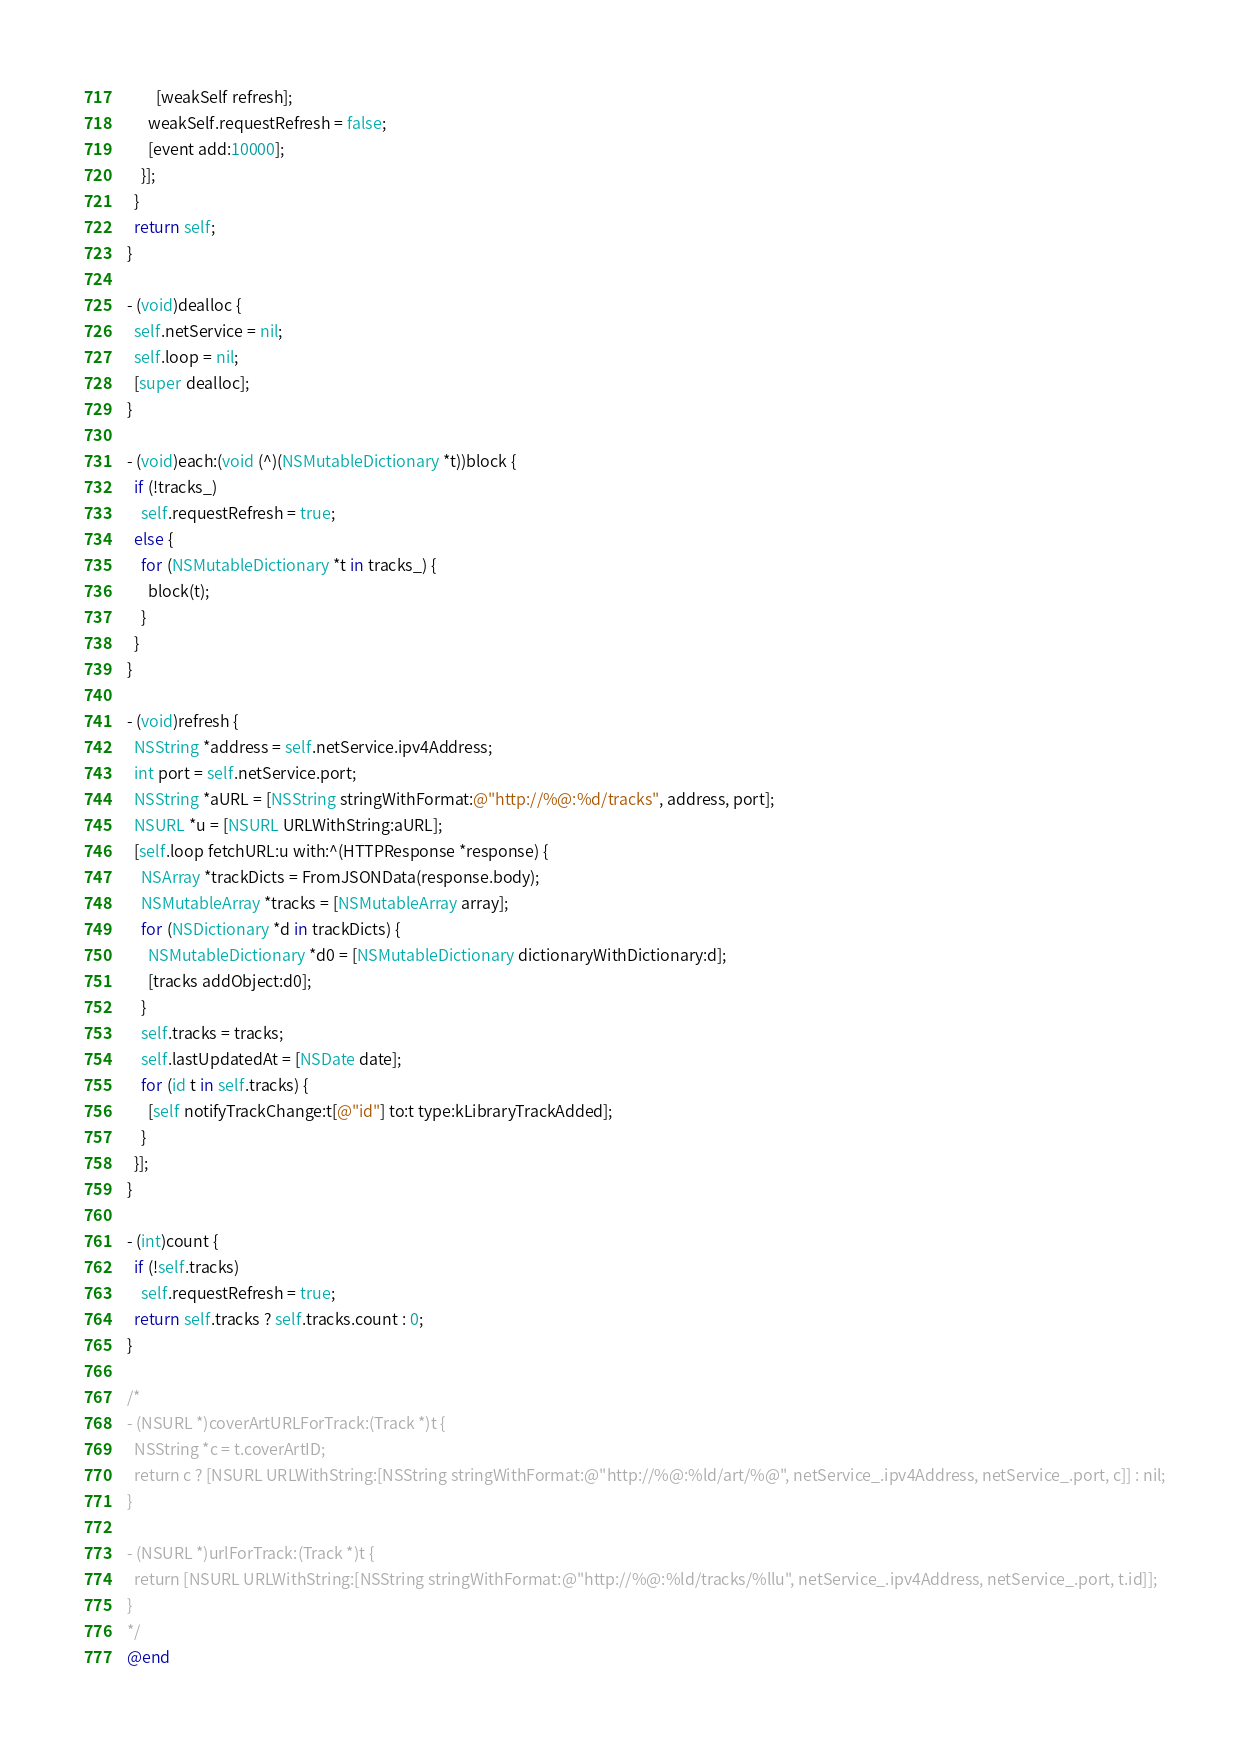Convert code to text. <code><loc_0><loc_0><loc_500><loc_500><_ObjectiveC_>        [weakSelf refresh];
      weakSelf.requestRefresh = false;
      [event add:10000];
    }];
  }
  return self;
}

- (void)dealloc {
  self.netService = nil;
  self.loop = nil;
  [super dealloc];
}

- (void)each:(void (^)(NSMutableDictionary *t))block {
  if (!tracks_)
    self.requestRefresh = true;
  else {
    for (NSMutableDictionary *t in tracks_) {
      block(t);
    }
  }
}

- (void)refresh {
  NSString *address = self.netService.ipv4Address;
  int port = self.netService.port;
  NSString *aURL = [NSString stringWithFormat:@"http://%@:%d/tracks", address, port];
  NSURL *u = [NSURL URLWithString:aURL];
  [self.loop fetchURL:u with:^(HTTPResponse *response) {
    NSArray *trackDicts = FromJSONData(response.body);
    NSMutableArray *tracks = [NSMutableArray array];
    for (NSDictionary *d in trackDicts) {
      NSMutableDictionary *d0 = [NSMutableDictionary dictionaryWithDictionary:d];
      [tracks addObject:d0];
    }
    self.tracks = tracks;
    self.lastUpdatedAt = [NSDate date];
    for (id t in self.tracks) {
      [self notifyTrackChange:t[@"id"] to:t type:kLibraryTrackAdded];
    }
  }];
}

- (int)count {
  if (!self.tracks)
    self.requestRefresh = true;
  return self.tracks ? self.tracks.count : 0;
}

/*
- (NSURL *)coverArtURLForTrack:(Track *)t {
  NSString *c = t.coverArtID;
  return c ? [NSURL URLWithString:[NSString stringWithFormat:@"http://%@:%ld/art/%@", netService_.ipv4Address, netService_.port, c]] : nil;
}

- (NSURL *)urlForTrack:(Track *)t {
  return [NSURL URLWithString:[NSString stringWithFormat:@"http://%@:%ld/tracks/%llu", netService_.ipv4Address, netService_.port, t.id]];
}
*/
@end

</code> 